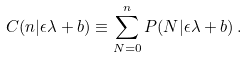Convert formula to latex. <formula><loc_0><loc_0><loc_500><loc_500>C ( n | \epsilon \lambda + b ) \equiv \sum _ { N = 0 } ^ { n } P ( N | \epsilon \lambda + b ) \, .</formula> 